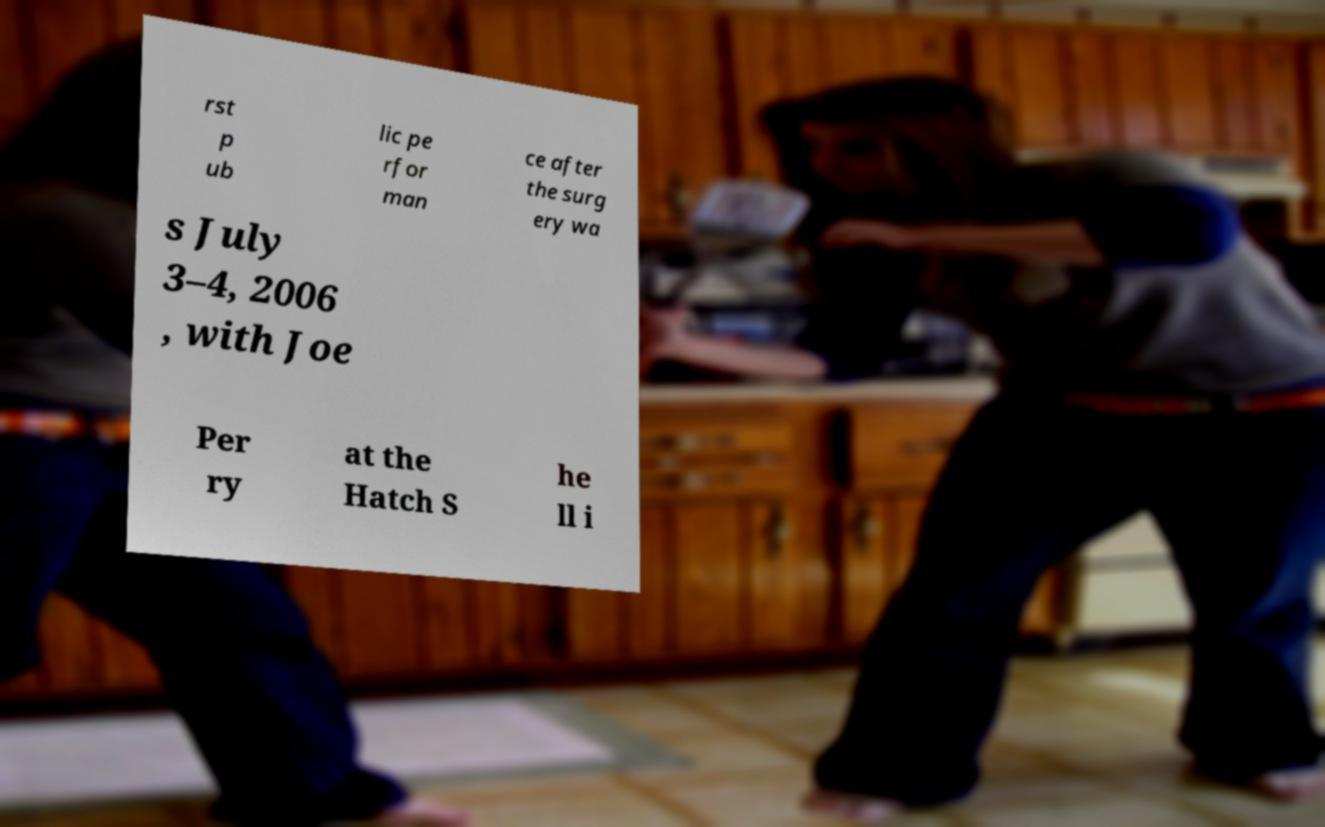Can you accurately transcribe the text from the provided image for me? rst p ub lic pe rfor man ce after the surg ery wa s July 3–4, 2006 , with Joe Per ry at the Hatch S he ll i 